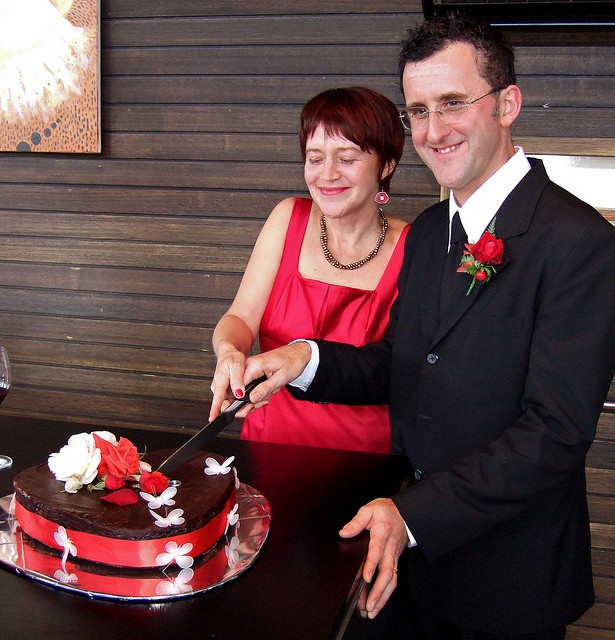Describe the objects in this image and their specific colors. I can see people in white, black, lightpink, and brown tones, dining table in white, black, maroon, brown, and lightgray tones, people in white, lightpink, red, black, and brown tones, cake in white, black, maroon, and red tones, and knife in white, black, maroon, gray, and darkgray tones in this image. 